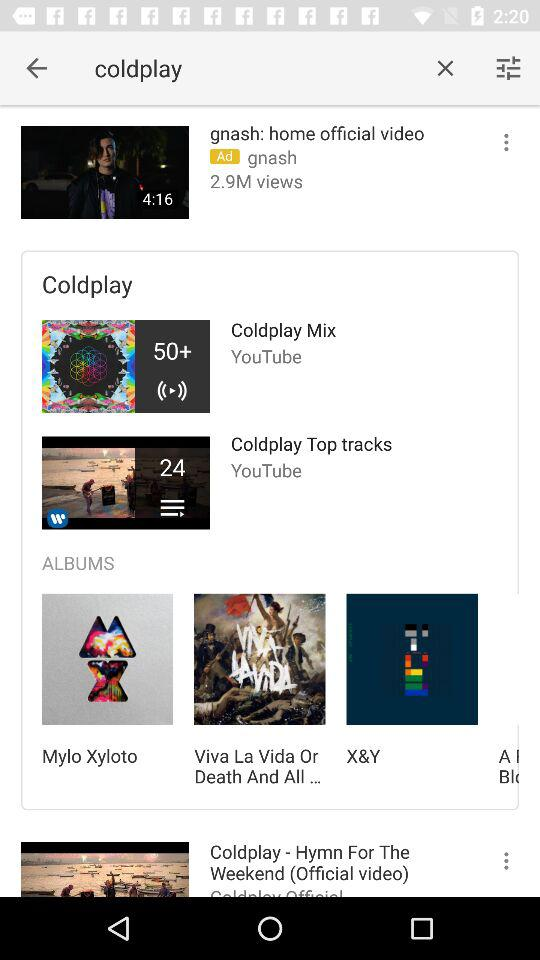What's the number of views of "gnash: home official video"? The number of views of "gnash: home official video" is 2.9M. 